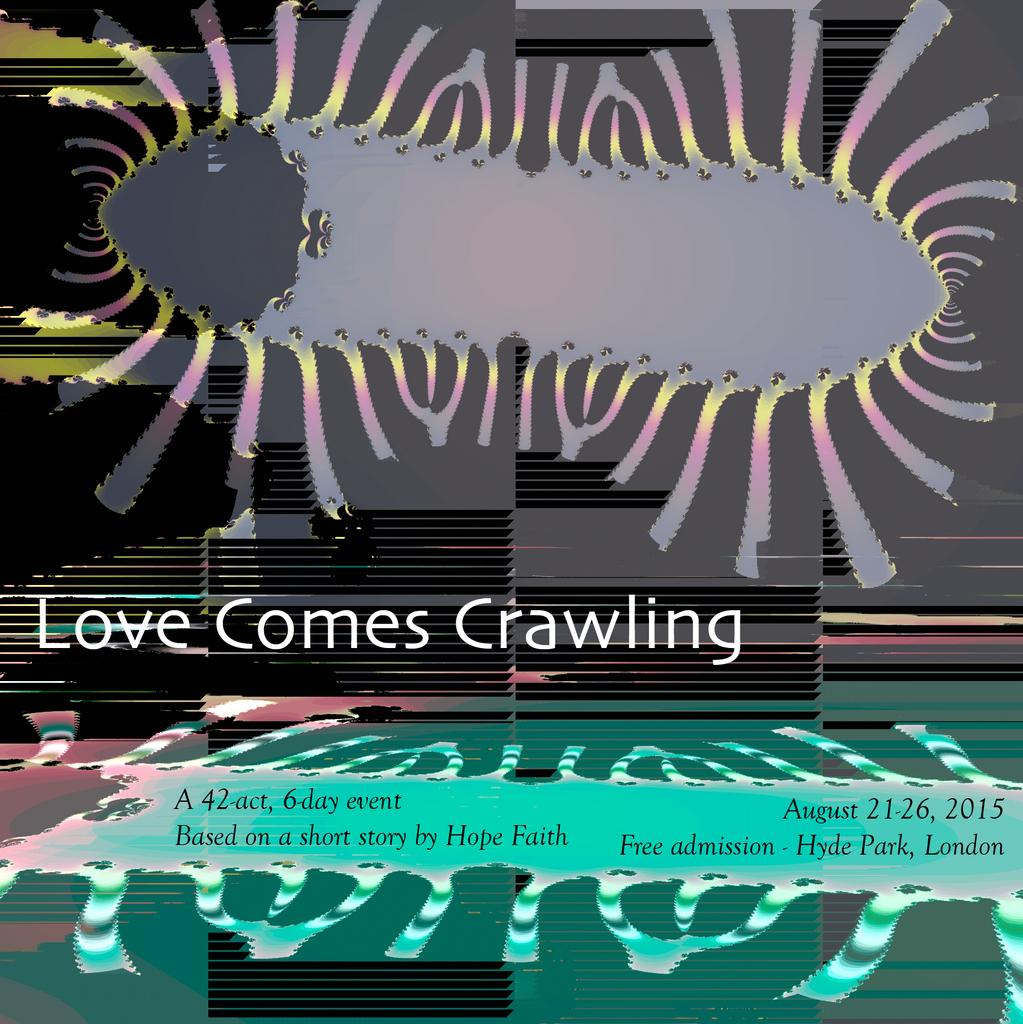<image>
Provide a brief description of the given image. A sign that says Love Comes Crawling includes a picture of a bug. 